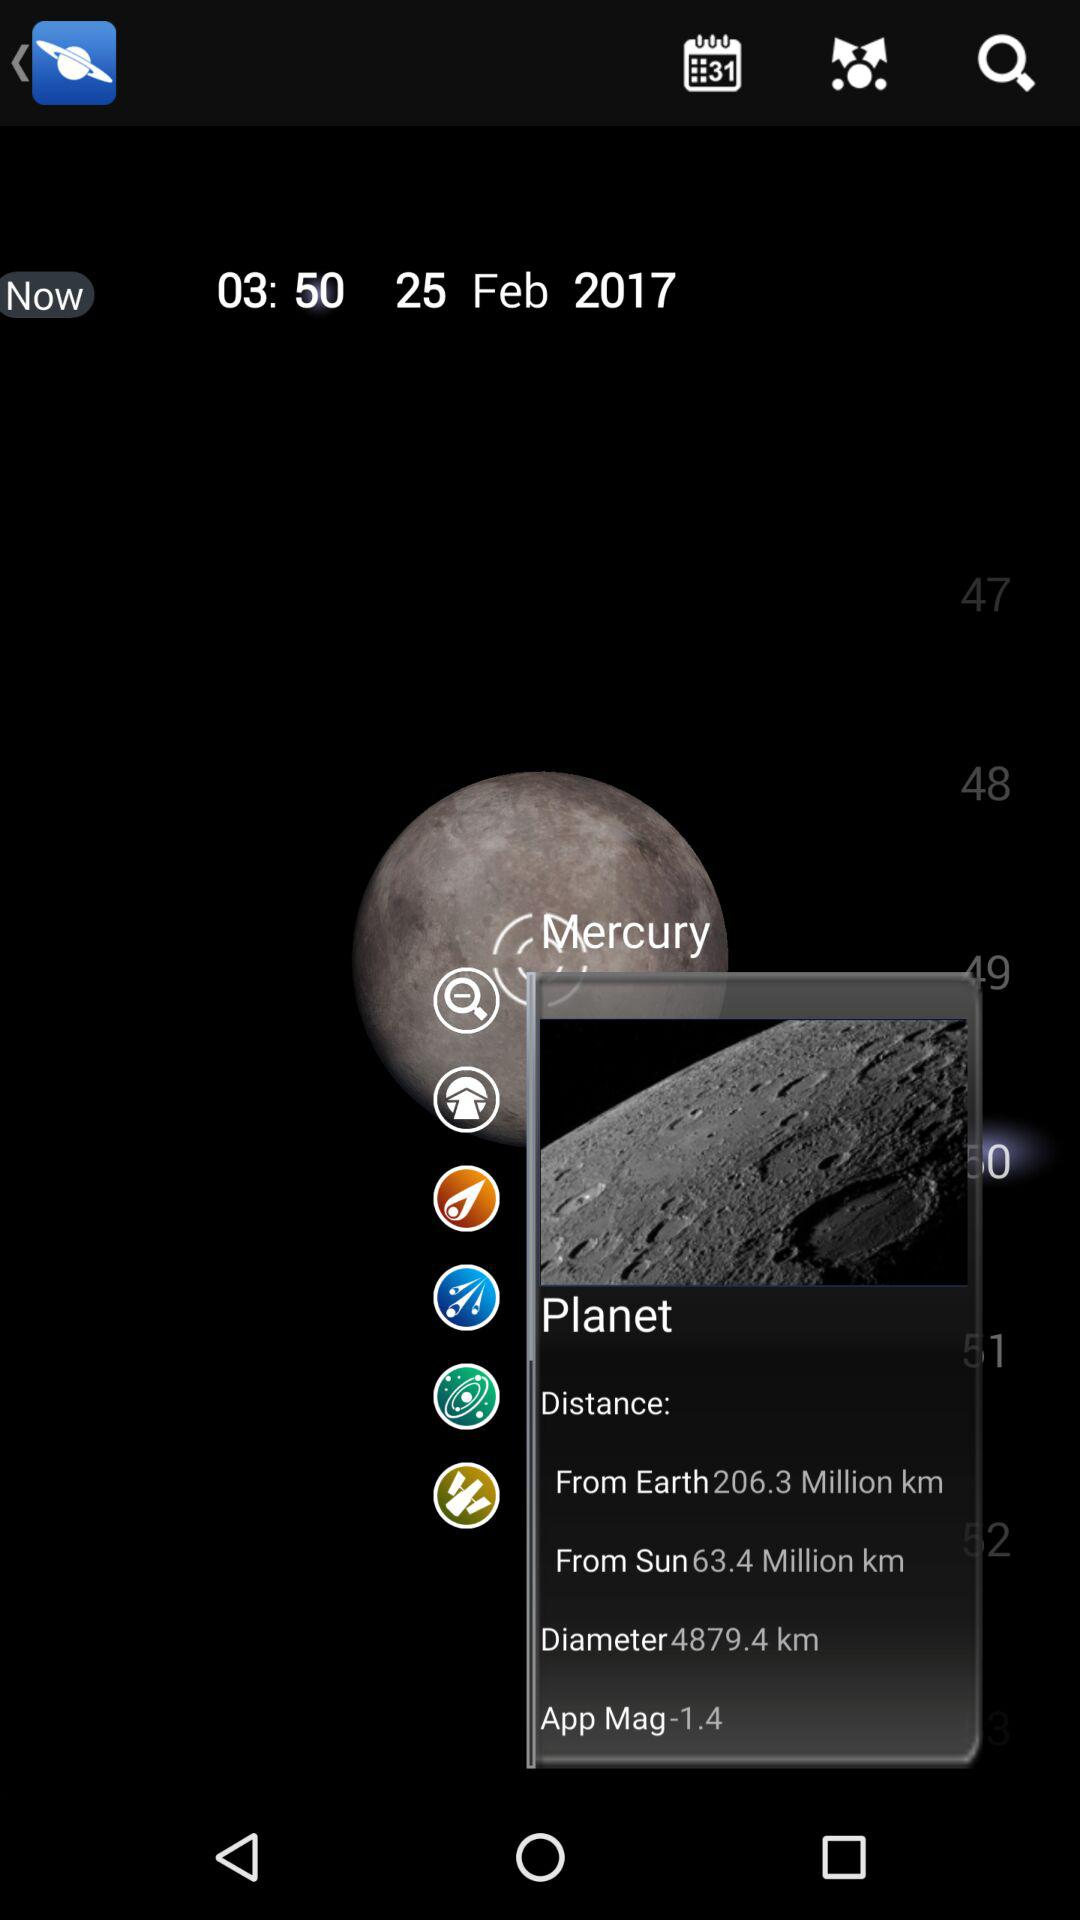What is the diameter of Mercury?
Answer the question using a single word or phrase. 4879.4 km 